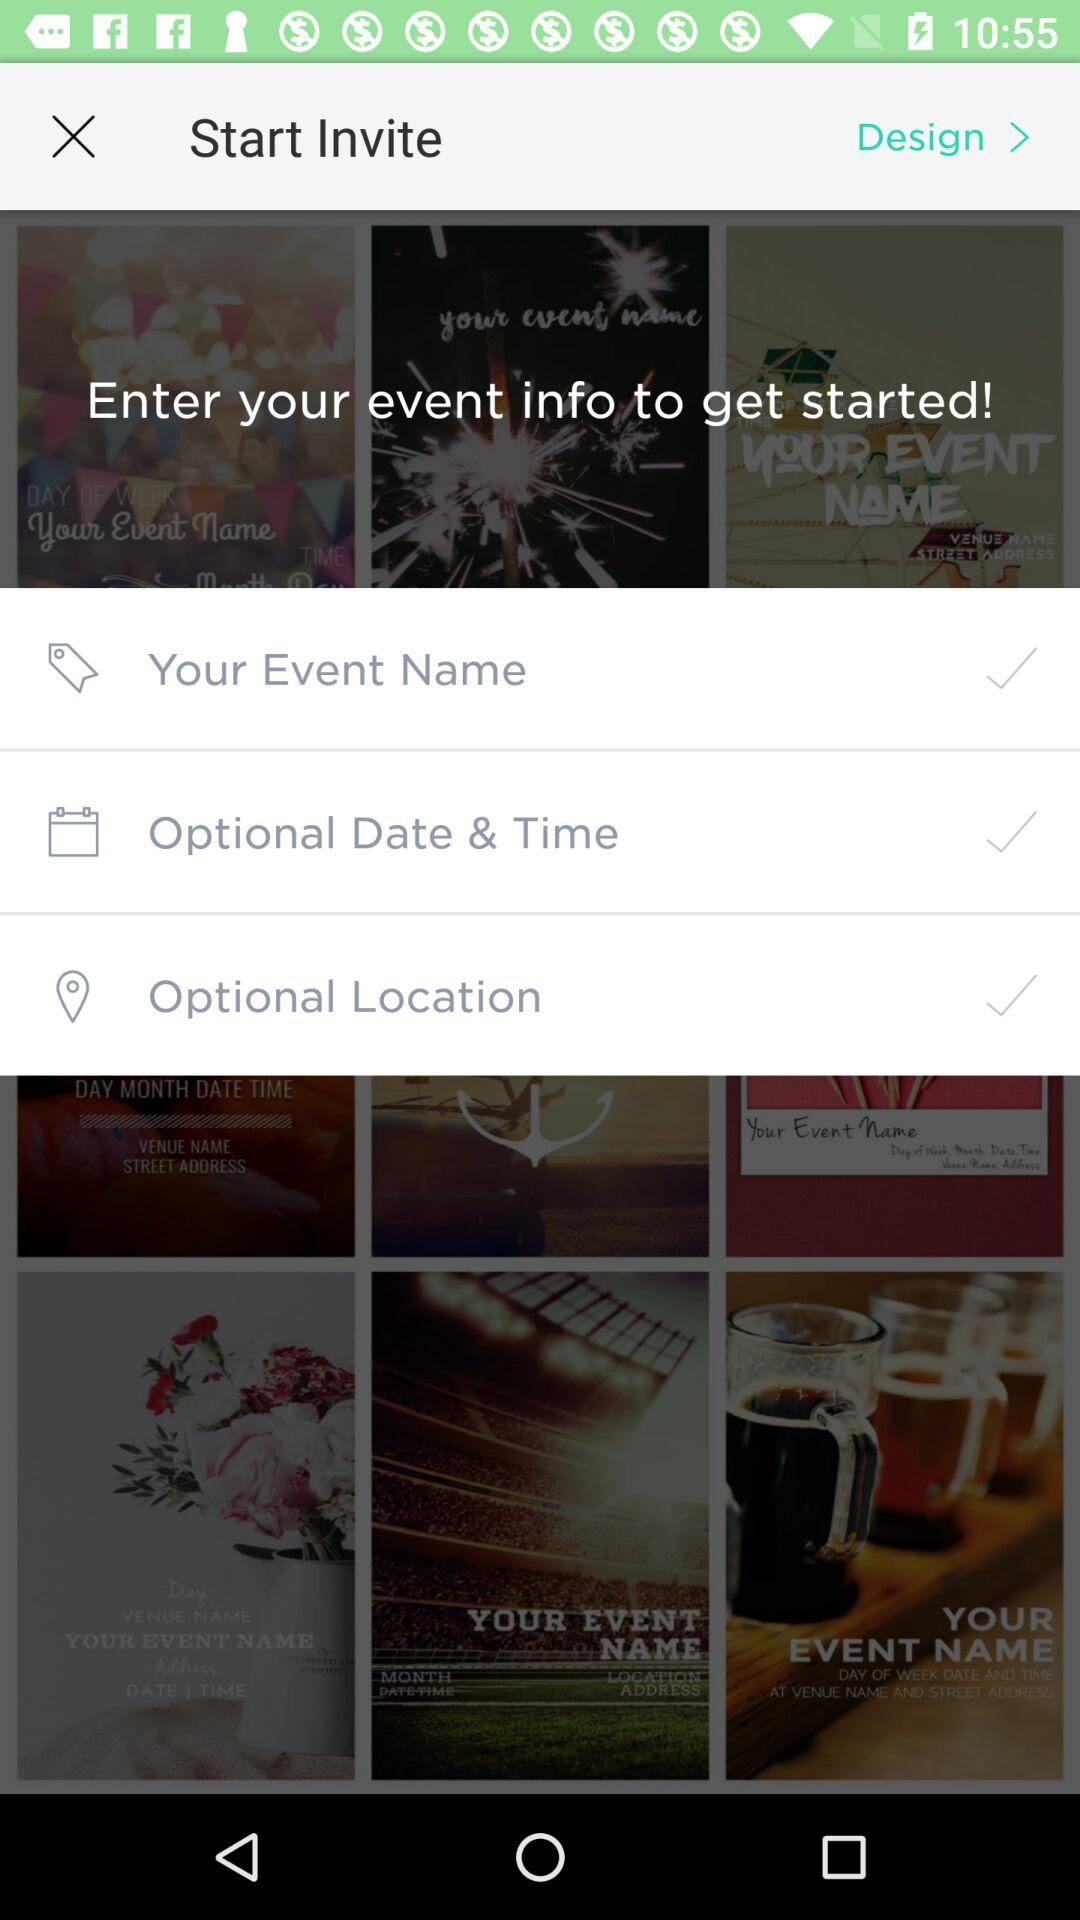How many check marks are there on the screen?
Answer the question using a single word or phrase. 3 